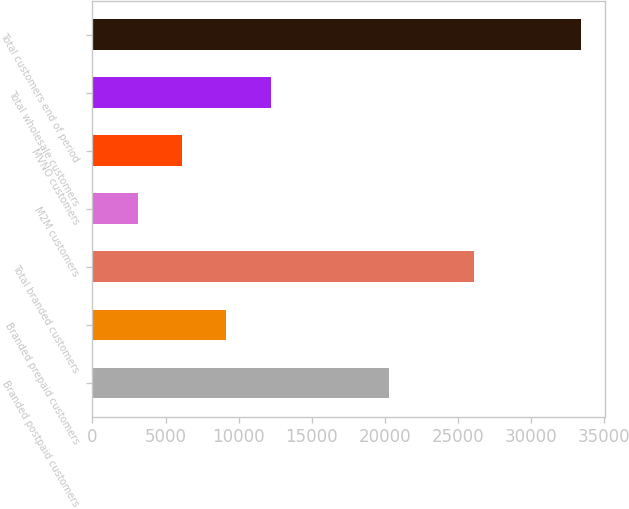Convert chart. <chart><loc_0><loc_0><loc_500><loc_500><bar_chart><fcel>Branded postpaid customers<fcel>Branded prepaid customers<fcel>Total branded customers<fcel>M2M customers<fcel>MVNO customers<fcel>Total wholesale customers<fcel>Total customers end of period<nl><fcel>20293<fcel>9149.8<fcel>26119<fcel>3090<fcel>6119.9<fcel>12179.7<fcel>33389<nl></chart> 